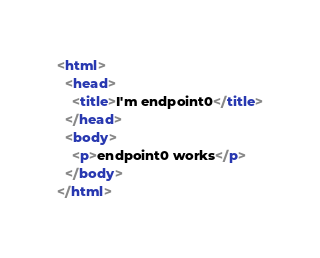<code> <loc_0><loc_0><loc_500><loc_500><_HTML_><html>
  <head>
    <title>I'm endpoint0</title>
  </head>
  <body>
    <p>endpoint0 works</p>
  </body>
</html>
</code> 